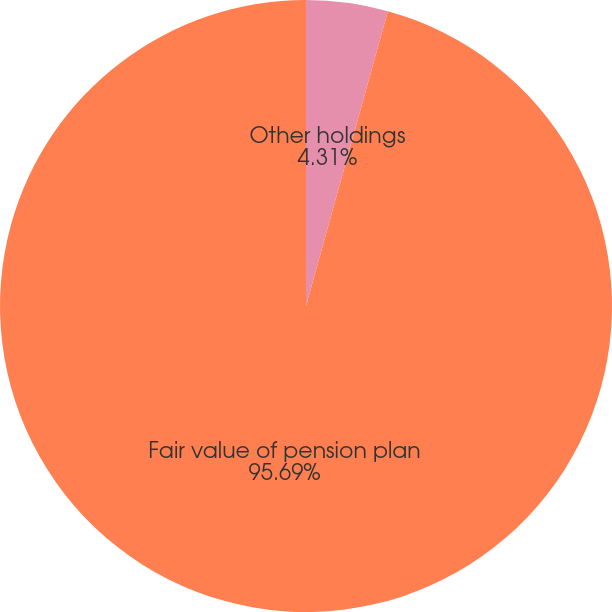Convert chart. <chart><loc_0><loc_0><loc_500><loc_500><pie_chart><fcel>Other holdings<fcel>Fair value of pension plan<nl><fcel>4.31%<fcel>95.69%<nl></chart> 